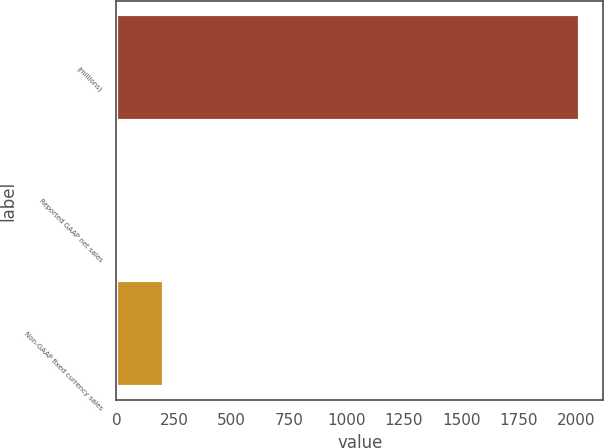Convert chart. <chart><loc_0><loc_0><loc_500><loc_500><bar_chart><fcel>(millions)<fcel>Reported GAAP net sales<fcel>Non-GAAP fixed currency sales<nl><fcel>2017<fcel>5<fcel>206.2<nl></chart> 